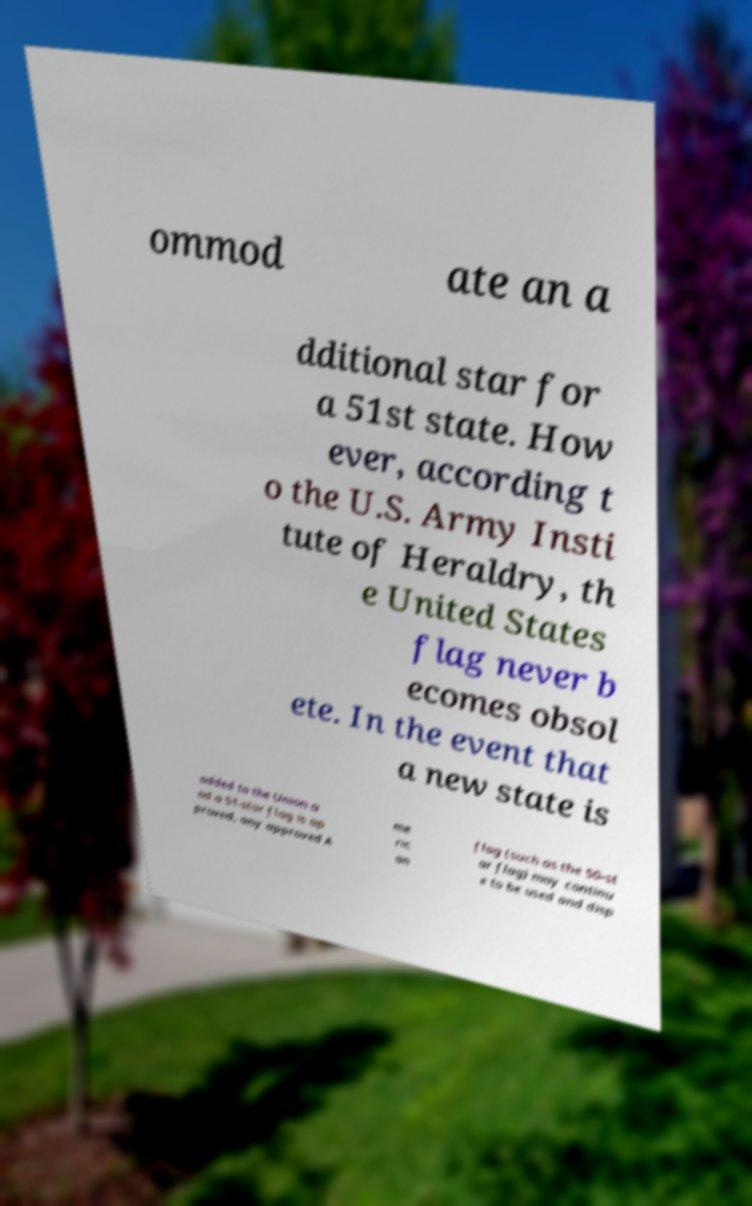For documentation purposes, I need the text within this image transcribed. Could you provide that? ommod ate an a dditional star for a 51st state. How ever, according t o the U.S. Army Insti tute of Heraldry, th e United States flag never b ecomes obsol ete. In the event that a new state is added to the Union a nd a 51-star flag is ap proved, any approved A me ric an flag (such as the 50-st ar flag) may continu e to be used and disp 